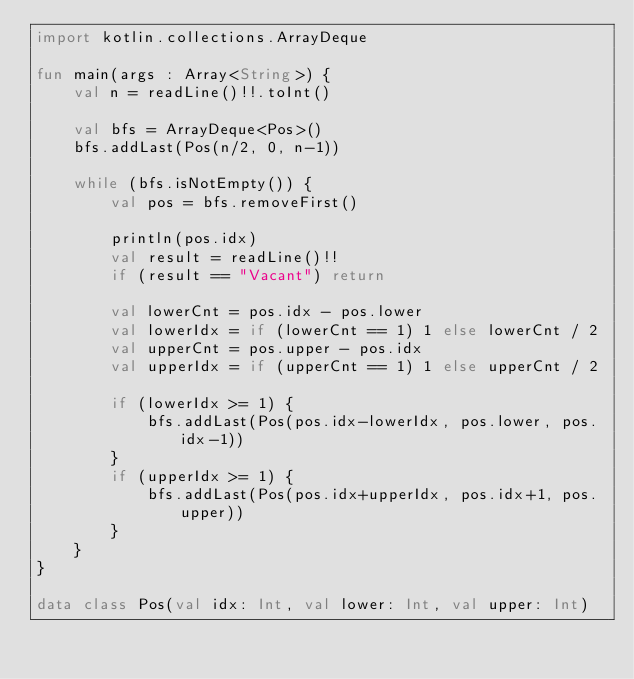<code> <loc_0><loc_0><loc_500><loc_500><_Kotlin_>import kotlin.collections.ArrayDeque

fun main(args : Array<String>) {
    val n = readLine()!!.toInt()

    val bfs = ArrayDeque<Pos>()
    bfs.addLast(Pos(n/2, 0, n-1))

    while (bfs.isNotEmpty()) {
        val pos = bfs.removeFirst()

        println(pos.idx)
        val result = readLine()!!
        if (result == "Vacant") return

        val lowerCnt = pos.idx - pos.lower
        val lowerIdx = if (lowerCnt == 1) 1 else lowerCnt / 2
        val upperCnt = pos.upper - pos.idx
        val upperIdx = if (upperCnt == 1) 1 else upperCnt / 2

        if (lowerIdx >= 1) {
            bfs.addLast(Pos(pos.idx-lowerIdx, pos.lower, pos.idx-1))
        }
        if (upperIdx >= 1) {
            bfs.addLast(Pos(pos.idx+upperIdx, pos.idx+1, pos.upper))
        }
    }
}

data class Pos(val idx: Int, val lower: Int, val upper: Int)</code> 